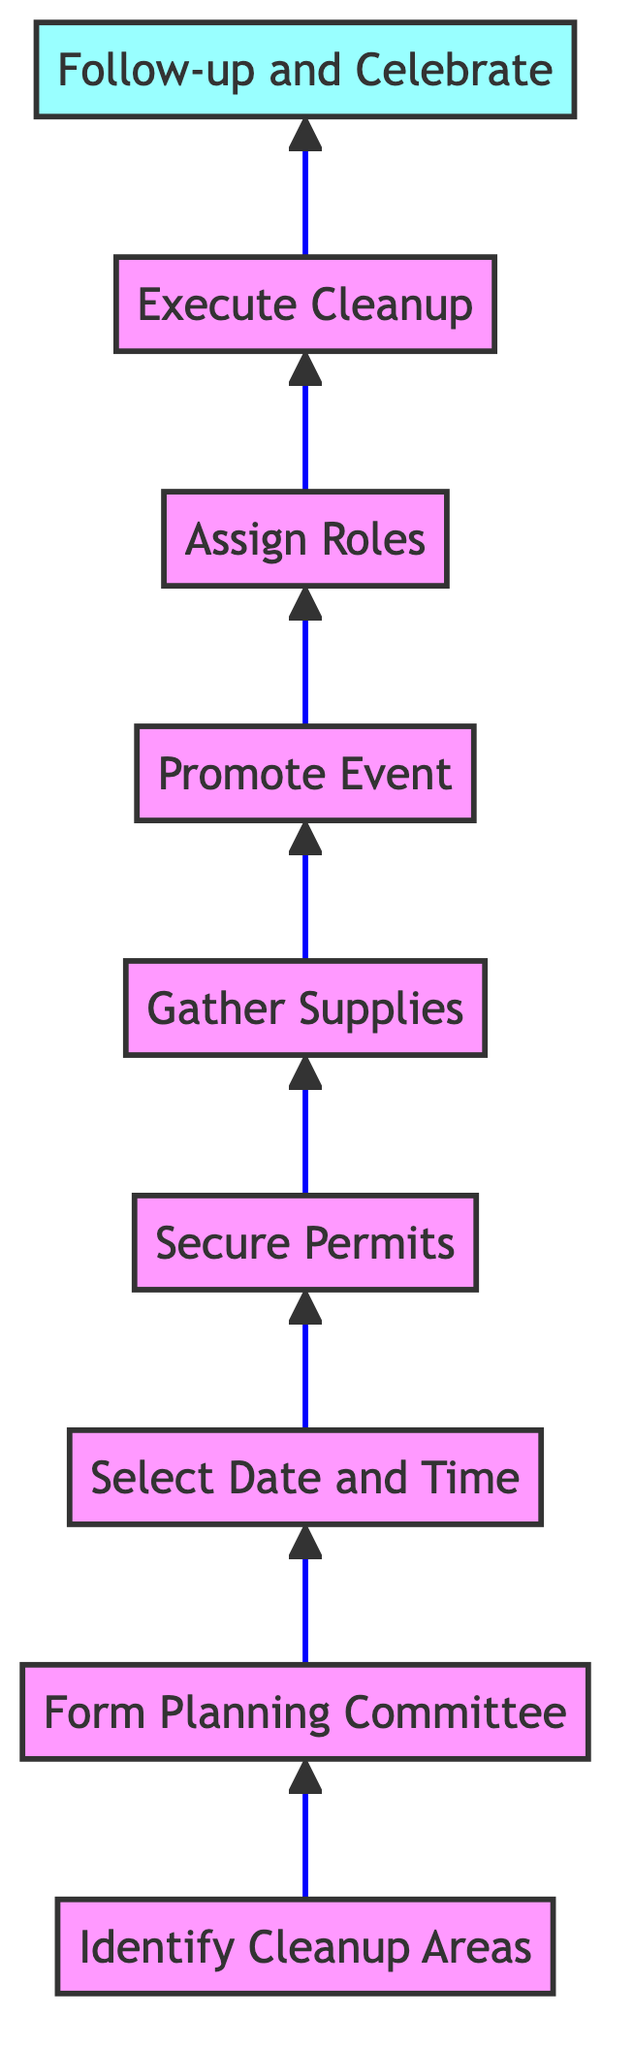What is the first step in the cleanup process? The first step listed in the diagram is "Identify the Cleanup Areas." This can be found at the bottom of the flowchart and is the starting point for the entire process.
Answer: Identify the Cleanup Areas How many total steps are there in the organizing process? By counting the steps in the flowchart from "Identify the Cleanup Areas" to "Follow-up and Celebrate," there are a total of 9 distinct steps in the process.
Answer: 9 What step comes immediately after securing permits? The step that follows "Secure Necessary Permits" in the flowchart is "Gather Supplies." This can be determined by moving up from the "Secure Permits" node to the next one directly above it.
Answer: Gather Supplies Which step is last in the cleanup sequence? The last step mentioned in the diagram is "Follow-up and Celebrate," which is located at the top of the flowchart and signifies the completion of the process.
Answer: Follow-up and Celebrate What action is taken before promoting the event? Before the "Promote the Event" step, the flowchart indicates to "Gather Supplies." This means that supplies must be collected prior to any promotion occurring.
Answer: Gather Supplies How many steps are there between selecting a date and executing the cleanup? There are 4 steps between "Select a Date and Time" and "Execute the Cleanup." These steps are "Secure Permits," "Gather Supplies," "Promote Event," and "Assign Roles and Responsibilities."
Answer: 4 What is the relationship between forming a planning committee and identifying cleanup areas? The relationship is that "Form a Planning Committee" directly follows "Identify the Cleanup Areas" in the flowchart. This indicates that assessing the areas leads to the formation of a committee to organize the cleanup.
Answer: Directly follows In the flowchart, what does each step represent? Each step represents a specific action or task that is part of the overall process of organizing a neighborhood cleanup, indicating a sequential process from planning to execution.
Answer: Specific action or task What characteristic is unique to the top node of this flowchart? The top node, which is "Follow-up and Celebrate," is unique because it signifies the finalization of the entire process, marking the completion and reflection on the cleanup effort.
Answer: Finalization of the process 